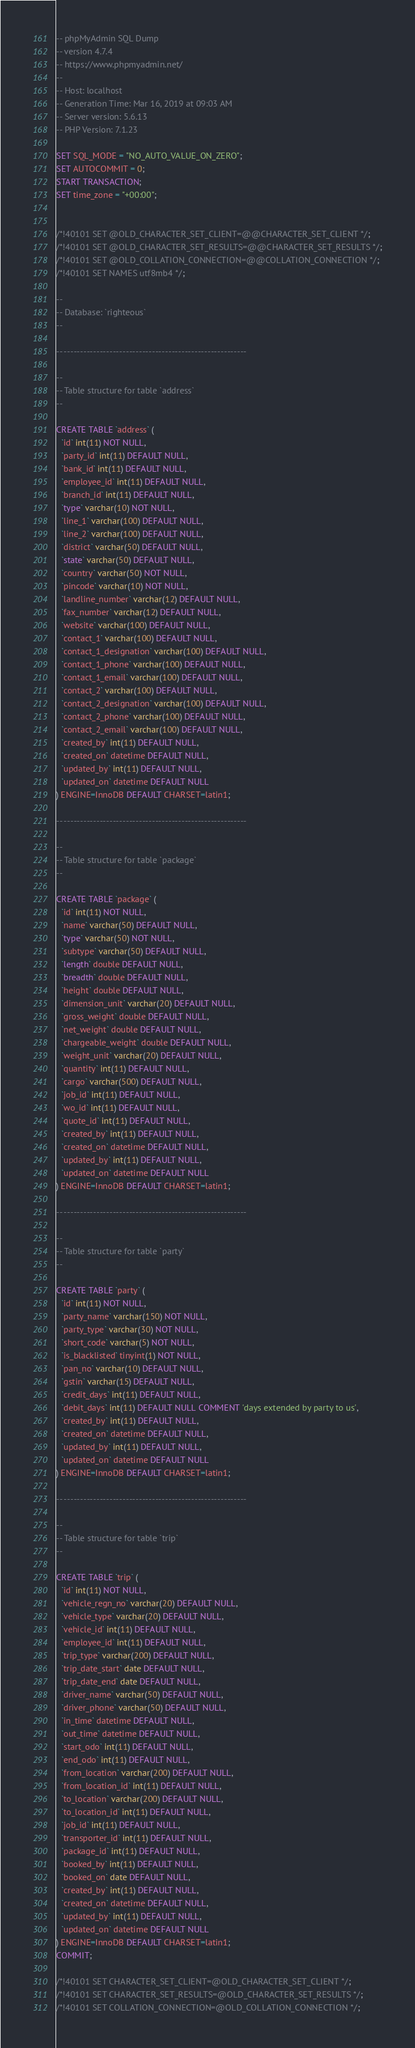Convert code to text. <code><loc_0><loc_0><loc_500><loc_500><_SQL_>-- phpMyAdmin SQL Dump
-- version 4.7.4
-- https://www.phpmyadmin.net/
--
-- Host: localhost
-- Generation Time: Mar 16, 2019 at 09:03 AM
-- Server version: 5.6.13
-- PHP Version: 7.1.23

SET SQL_MODE = "NO_AUTO_VALUE_ON_ZERO";
SET AUTOCOMMIT = 0;
START TRANSACTION;
SET time_zone = "+00:00";


/*!40101 SET @OLD_CHARACTER_SET_CLIENT=@@CHARACTER_SET_CLIENT */;
/*!40101 SET @OLD_CHARACTER_SET_RESULTS=@@CHARACTER_SET_RESULTS */;
/*!40101 SET @OLD_COLLATION_CONNECTION=@@COLLATION_CONNECTION */;
/*!40101 SET NAMES utf8mb4 */;

--
-- Database: `righteous`
--

-- --------------------------------------------------------

--
-- Table structure for table `address`
--

CREATE TABLE `address` (
  `id` int(11) NOT NULL,
  `party_id` int(11) DEFAULT NULL,
  `bank_id` int(11) DEFAULT NULL,
  `employee_id` int(11) DEFAULT NULL,
  `branch_id` int(11) DEFAULT NULL,
  `type` varchar(10) NOT NULL,
  `line_1` varchar(100) DEFAULT NULL,
  `line_2` varchar(100) DEFAULT NULL,
  `district` varchar(50) DEFAULT NULL,
  `state` varchar(50) DEFAULT NULL,
  `country` varchar(50) NOT NULL,
  `pincode` varchar(10) NOT NULL,
  `landline_number` varchar(12) DEFAULT NULL,
  `fax_number` varchar(12) DEFAULT NULL,
  `website` varchar(100) DEFAULT NULL,
  `contact_1` varchar(100) DEFAULT NULL,
  `contact_1_designation` varchar(100) DEFAULT NULL,
  `contact_1_phone` varchar(100) DEFAULT NULL,
  `contact_1_email` varchar(100) DEFAULT NULL,
  `contact_2` varchar(100) DEFAULT NULL,
  `contact_2_designation` varchar(100) DEFAULT NULL,
  `contact_2_phone` varchar(100) DEFAULT NULL,
  `contact_2_email` varchar(100) DEFAULT NULL,
  `created_by` int(11) DEFAULT NULL,
  `created_on` datetime DEFAULT NULL,
  `updated_by` int(11) DEFAULT NULL,
  `updated_on` datetime DEFAULT NULL
) ENGINE=InnoDB DEFAULT CHARSET=latin1;

-- --------------------------------------------------------

--
-- Table structure for table `package`
--

CREATE TABLE `package` (
  `id` int(11) NOT NULL,
  `name` varchar(50) DEFAULT NULL,
  `type` varchar(50) NOT NULL,
  `subtype` varchar(50) DEFAULT NULL,
  `length` double DEFAULT NULL,
  `breadth` double DEFAULT NULL,
  `height` double DEFAULT NULL,
  `dimension_unit` varchar(20) DEFAULT NULL,
  `gross_weight` double DEFAULT NULL,
  `net_weight` double DEFAULT NULL,
  `chargeable_weight` double DEFAULT NULL,
  `weight_unit` varchar(20) DEFAULT NULL,
  `quantity` int(11) DEFAULT NULL,
  `cargo` varchar(500) DEFAULT NULL,
  `job_id` int(11) DEFAULT NULL,
  `wo_id` int(11) DEFAULT NULL,
  `quote_id` int(11) DEFAULT NULL,
  `created_by` int(11) DEFAULT NULL,
  `created_on` datetime DEFAULT NULL,
  `updated_by` int(11) DEFAULT NULL,
  `updated_on` datetime DEFAULT NULL
) ENGINE=InnoDB DEFAULT CHARSET=latin1;

-- --------------------------------------------------------

--
-- Table structure for table `party`
--

CREATE TABLE `party` (
  `id` int(11) NOT NULL,
  `party_name` varchar(150) NOT NULL,
  `party_type` varchar(30) NOT NULL,
  `short_code` varchar(5) NOT NULL,
  `is_blacklisted` tinyint(1) NOT NULL,
  `pan_no` varchar(10) DEFAULT NULL,
  `gstin` varchar(15) DEFAULT NULL,
  `credit_days` int(11) DEFAULT NULL,
  `debit_days` int(11) DEFAULT NULL COMMENT 'days extended by party to us',
  `created_by` int(11) DEFAULT NULL,
  `created_on` datetime DEFAULT NULL,
  `updated_by` int(11) DEFAULT NULL,
  `updated_on` datetime DEFAULT NULL
) ENGINE=InnoDB DEFAULT CHARSET=latin1;

-- --------------------------------------------------------

--
-- Table structure for table `trip`
--

CREATE TABLE `trip` (
  `id` int(11) NOT NULL,
  `vehicle_regn_no` varchar(20) DEFAULT NULL,
  `vehicle_type` varchar(20) DEFAULT NULL,
  `vehicle_id` int(11) DEFAULT NULL,
  `employee_id` int(11) DEFAULT NULL,
  `trip_type` varchar(200) DEFAULT NULL,
  `trip_date_start` date DEFAULT NULL,
  `trip_date_end` date DEFAULT NULL,
  `driver_name` varchar(50) DEFAULT NULL,
  `driver_phone` varchar(50) DEFAULT NULL,
  `in_time` datetime DEFAULT NULL,
  `out_time` datetime DEFAULT NULL,
  `start_odo` int(11) DEFAULT NULL,
  `end_odo` int(11) DEFAULT NULL,
  `from_location` varchar(200) DEFAULT NULL,
  `from_location_id` int(11) DEFAULT NULL,
  `to_location` varchar(200) DEFAULT NULL,
  `to_location_id` int(11) DEFAULT NULL,
  `job_id` int(11) DEFAULT NULL,
  `transporter_id` int(11) DEFAULT NULL,
  `package_id` int(11) DEFAULT NULL,
  `booked_by` int(11) DEFAULT NULL,
  `booked_on` date DEFAULT NULL,
  `created_by` int(11) DEFAULT NULL,
  `created_on` datetime DEFAULT NULL,
  `updated_by` int(11) DEFAULT NULL,
  `updated_on` datetime DEFAULT NULL
) ENGINE=InnoDB DEFAULT CHARSET=latin1;
COMMIT;

/*!40101 SET CHARACTER_SET_CLIENT=@OLD_CHARACTER_SET_CLIENT */;
/*!40101 SET CHARACTER_SET_RESULTS=@OLD_CHARACTER_SET_RESULTS */;
/*!40101 SET COLLATION_CONNECTION=@OLD_COLLATION_CONNECTION */;
</code> 